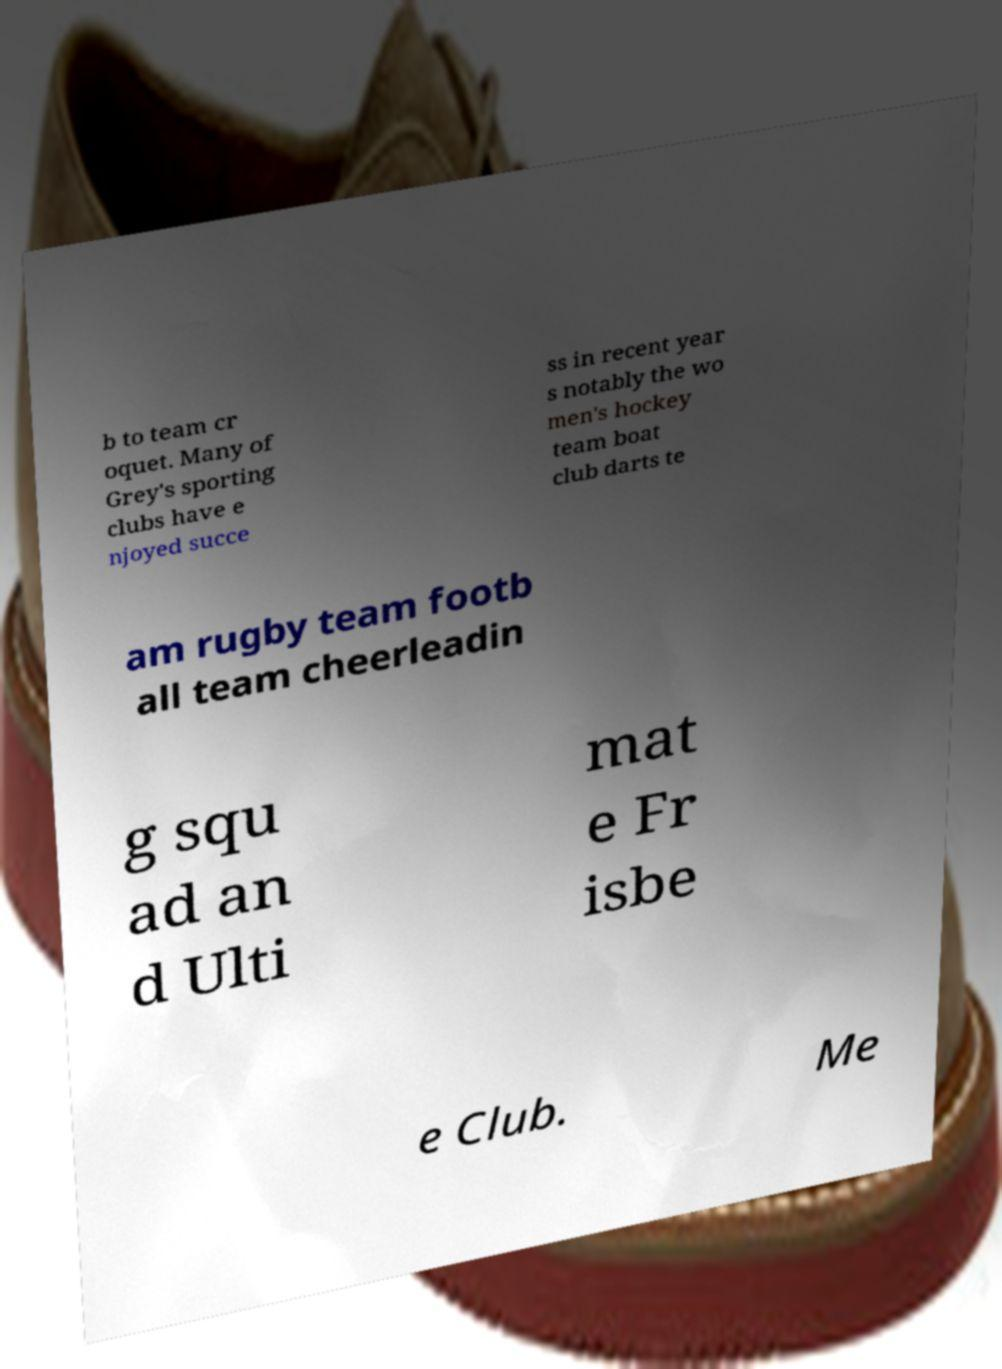For documentation purposes, I need the text within this image transcribed. Could you provide that? b to team cr oquet. Many of Grey's sporting clubs have e njoyed succe ss in recent year s notably the wo men's hockey team boat club darts te am rugby team footb all team cheerleadin g squ ad an d Ulti mat e Fr isbe e Club. Me 